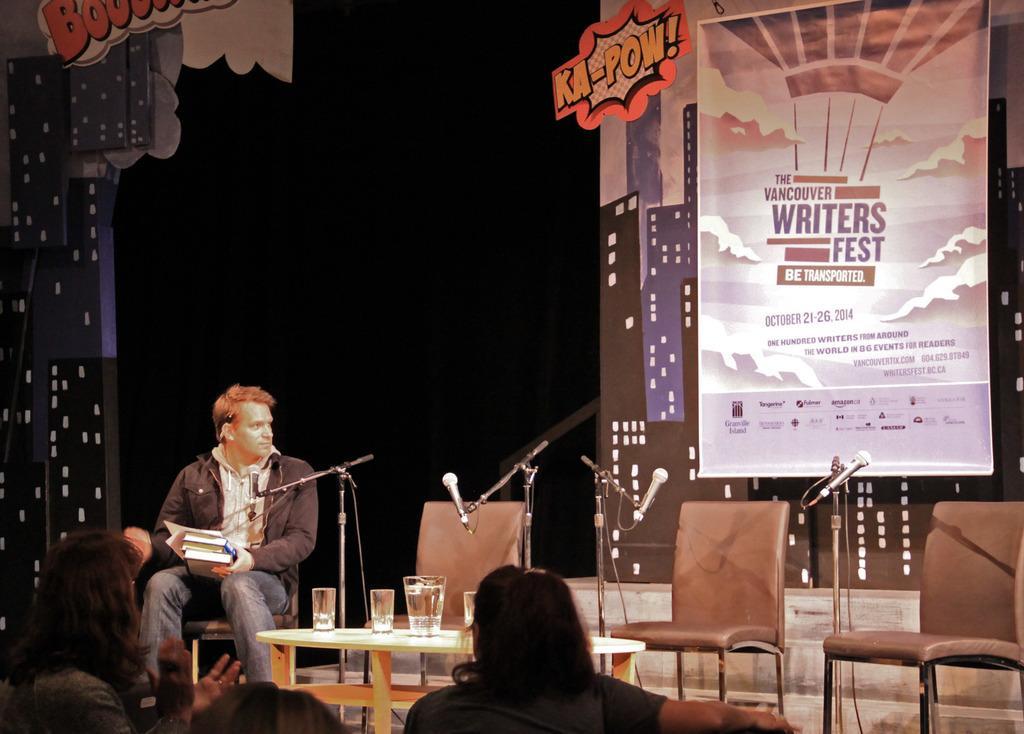In one or two sentences, can you explain what this image depicts? It seems to be the image is inside a hall. In the image on left side there is a man holding books and sitting on chair in front of a microphone and there is a table, on table we can see few water glasses. On right side there are some hoardings. 